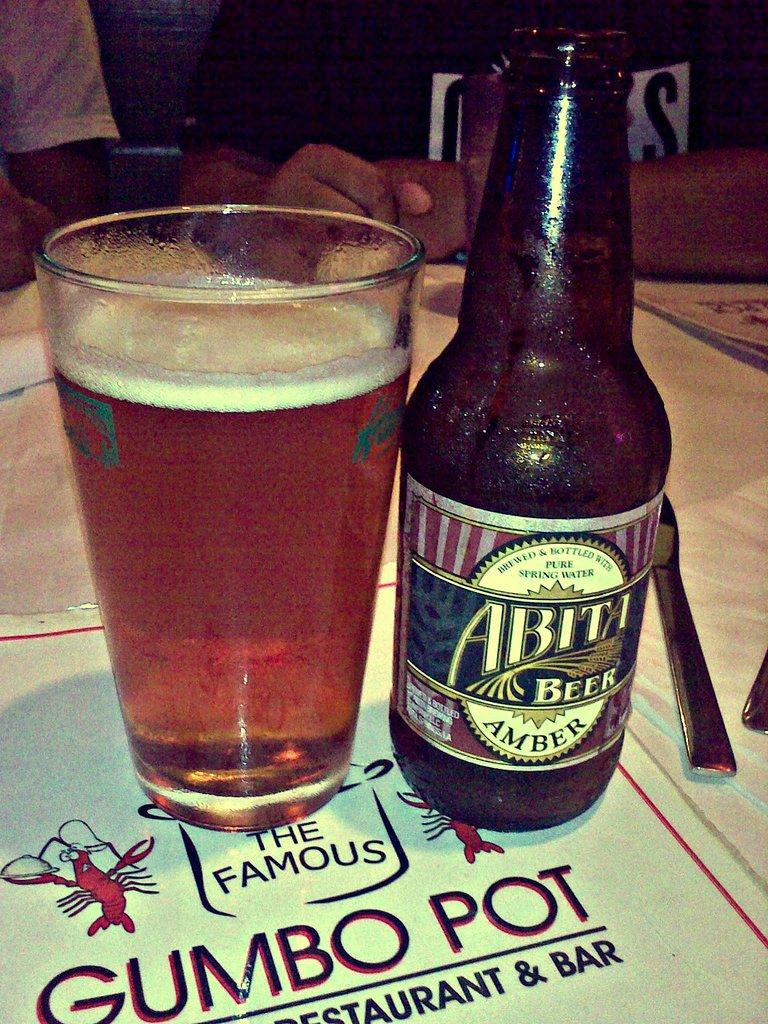<image>
Provide a brief description of the given image. Abita Amber Beer bottle and 3/4 filled pint glass sitting atop The Famous Gumbo Pot menu. 